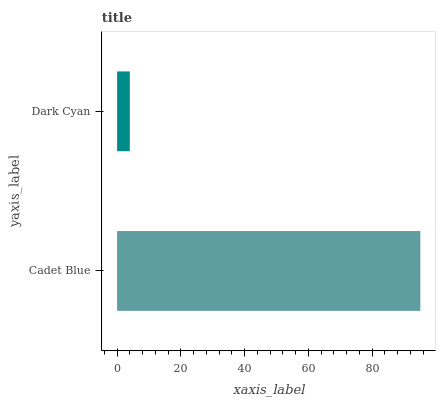Is Dark Cyan the minimum?
Answer yes or no. Yes. Is Cadet Blue the maximum?
Answer yes or no. Yes. Is Dark Cyan the maximum?
Answer yes or no. No. Is Cadet Blue greater than Dark Cyan?
Answer yes or no. Yes. Is Dark Cyan less than Cadet Blue?
Answer yes or no. Yes. Is Dark Cyan greater than Cadet Blue?
Answer yes or no. No. Is Cadet Blue less than Dark Cyan?
Answer yes or no. No. Is Cadet Blue the high median?
Answer yes or no. Yes. Is Dark Cyan the low median?
Answer yes or no. Yes. Is Dark Cyan the high median?
Answer yes or no. No. Is Cadet Blue the low median?
Answer yes or no. No. 